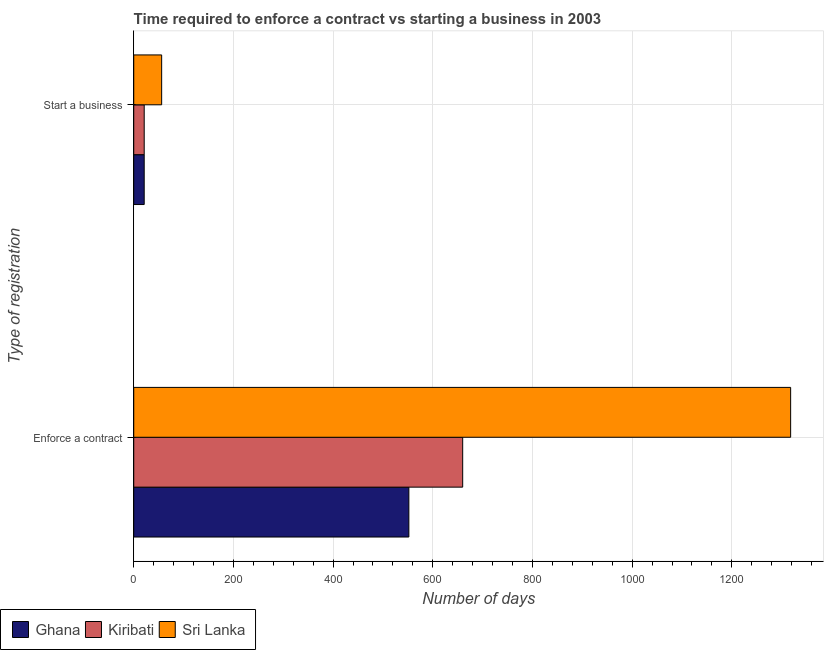How many different coloured bars are there?
Ensure brevity in your answer.  3. Are the number of bars per tick equal to the number of legend labels?
Your answer should be compact. Yes. What is the label of the 1st group of bars from the top?
Your response must be concise. Start a business. What is the number of days to start a business in Sri Lanka?
Offer a terse response. 56. Across all countries, what is the maximum number of days to enforece a contract?
Keep it short and to the point. 1318. Across all countries, what is the minimum number of days to enforece a contract?
Ensure brevity in your answer.  552. In which country was the number of days to enforece a contract maximum?
Your answer should be very brief. Sri Lanka. In which country was the number of days to enforece a contract minimum?
Offer a very short reply. Ghana. What is the total number of days to start a business in the graph?
Offer a terse response. 98. What is the difference between the number of days to enforece a contract in Kiribati and that in Sri Lanka?
Make the answer very short. -658. What is the difference between the number of days to start a business in Ghana and the number of days to enforece a contract in Kiribati?
Keep it short and to the point. -639. What is the average number of days to start a business per country?
Provide a short and direct response. 32.67. What is the difference between the number of days to start a business and number of days to enforece a contract in Kiribati?
Give a very brief answer. -639. In how many countries, is the number of days to enforece a contract greater than 1040 days?
Your answer should be compact. 1. What is the ratio of the number of days to enforece a contract in Ghana to that in Kiribati?
Your answer should be very brief. 0.84. In how many countries, is the number of days to enforece a contract greater than the average number of days to enforece a contract taken over all countries?
Your response must be concise. 1. What does the 2nd bar from the top in Enforce a contract represents?
Offer a very short reply. Kiribati. What does the 2nd bar from the bottom in Enforce a contract represents?
Offer a terse response. Kiribati. Are all the bars in the graph horizontal?
Your answer should be very brief. Yes. Are the values on the major ticks of X-axis written in scientific E-notation?
Ensure brevity in your answer.  No. Does the graph contain grids?
Your response must be concise. Yes. How many legend labels are there?
Provide a short and direct response. 3. What is the title of the graph?
Ensure brevity in your answer.  Time required to enforce a contract vs starting a business in 2003. What is the label or title of the X-axis?
Your response must be concise. Number of days. What is the label or title of the Y-axis?
Keep it short and to the point. Type of registration. What is the Number of days of Ghana in Enforce a contract?
Provide a succinct answer. 552. What is the Number of days in Kiribati in Enforce a contract?
Your response must be concise. 660. What is the Number of days of Sri Lanka in Enforce a contract?
Give a very brief answer. 1318. What is the Number of days in Ghana in Start a business?
Give a very brief answer. 21. What is the Number of days of Kiribati in Start a business?
Make the answer very short. 21. What is the Number of days in Sri Lanka in Start a business?
Keep it short and to the point. 56. Across all Type of registration, what is the maximum Number of days of Ghana?
Offer a very short reply. 552. Across all Type of registration, what is the maximum Number of days in Kiribati?
Give a very brief answer. 660. Across all Type of registration, what is the maximum Number of days of Sri Lanka?
Provide a succinct answer. 1318. Across all Type of registration, what is the minimum Number of days of Kiribati?
Provide a short and direct response. 21. Across all Type of registration, what is the minimum Number of days in Sri Lanka?
Make the answer very short. 56. What is the total Number of days of Ghana in the graph?
Provide a short and direct response. 573. What is the total Number of days in Kiribati in the graph?
Provide a short and direct response. 681. What is the total Number of days of Sri Lanka in the graph?
Provide a short and direct response. 1374. What is the difference between the Number of days in Ghana in Enforce a contract and that in Start a business?
Your answer should be very brief. 531. What is the difference between the Number of days in Kiribati in Enforce a contract and that in Start a business?
Provide a succinct answer. 639. What is the difference between the Number of days of Sri Lanka in Enforce a contract and that in Start a business?
Provide a succinct answer. 1262. What is the difference between the Number of days of Ghana in Enforce a contract and the Number of days of Kiribati in Start a business?
Offer a very short reply. 531. What is the difference between the Number of days of Ghana in Enforce a contract and the Number of days of Sri Lanka in Start a business?
Provide a short and direct response. 496. What is the difference between the Number of days in Kiribati in Enforce a contract and the Number of days in Sri Lanka in Start a business?
Your response must be concise. 604. What is the average Number of days in Ghana per Type of registration?
Your response must be concise. 286.5. What is the average Number of days in Kiribati per Type of registration?
Provide a short and direct response. 340.5. What is the average Number of days of Sri Lanka per Type of registration?
Offer a terse response. 687. What is the difference between the Number of days in Ghana and Number of days in Kiribati in Enforce a contract?
Keep it short and to the point. -108. What is the difference between the Number of days in Ghana and Number of days in Sri Lanka in Enforce a contract?
Make the answer very short. -766. What is the difference between the Number of days of Kiribati and Number of days of Sri Lanka in Enforce a contract?
Provide a short and direct response. -658. What is the difference between the Number of days of Ghana and Number of days of Sri Lanka in Start a business?
Offer a very short reply. -35. What is the difference between the Number of days of Kiribati and Number of days of Sri Lanka in Start a business?
Ensure brevity in your answer.  -35. What is the ratio of the Number of days in Ghana in Enforce a contract to that in Start a business?
Give a very brief answer. 26.29. What is the ratio of the Number of days in Kiribati in Enforce a contract to that in Start a business?
Offer a terse response. 31.43. What is the ratio of the Number of days in Sri Lanka in Enforce a contract to that in Start a business?
Offer a terse response. 23.54. What is the difference between the highest and the second highest Number of days in Ghana?
Make the answer very short. 531. What is the difference between the highest and the second highest Number of days of Kiribati?
Your answer should be compact. 639. What is the difference between the highest and the second highest Number of days of Sri Lanka?
Your answer should be very brief. 1262. What is the difference between the highest and the lowest Number of days in Ghana?
Your response must be concise. 531. What is the difference between the highest and the lowest Number of days of Kiribati?
Your response must be concise. 639. What is the difference between the highest and the lowest Number of days of Sri Lanka?
Provide a short and direct response. 1262. 